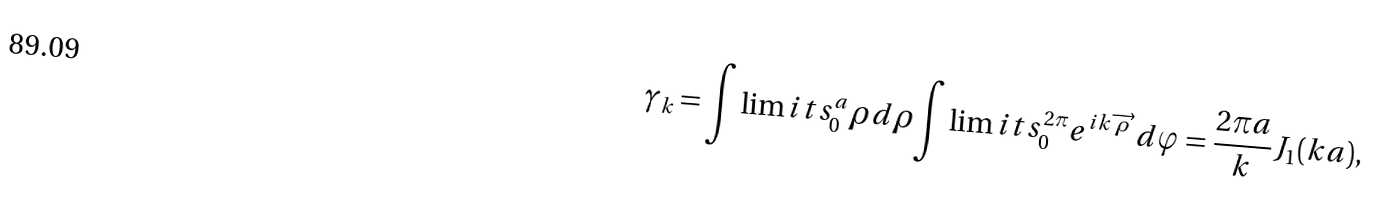<formula> <loc_0><loc_0><loc_500><loc_500>\gamma _ { k } = { \int \lim i t s _ { 0 } ^ { a } } \rho d \rho { \int \lim i t s _ { 0 } ^ { 2 \pi } } e ^ { i { k } \overrightarrow { \rho } } d \varphi = \frac { 2 \pi a } k J _ { 1 } ( k a ) ,</formula> 